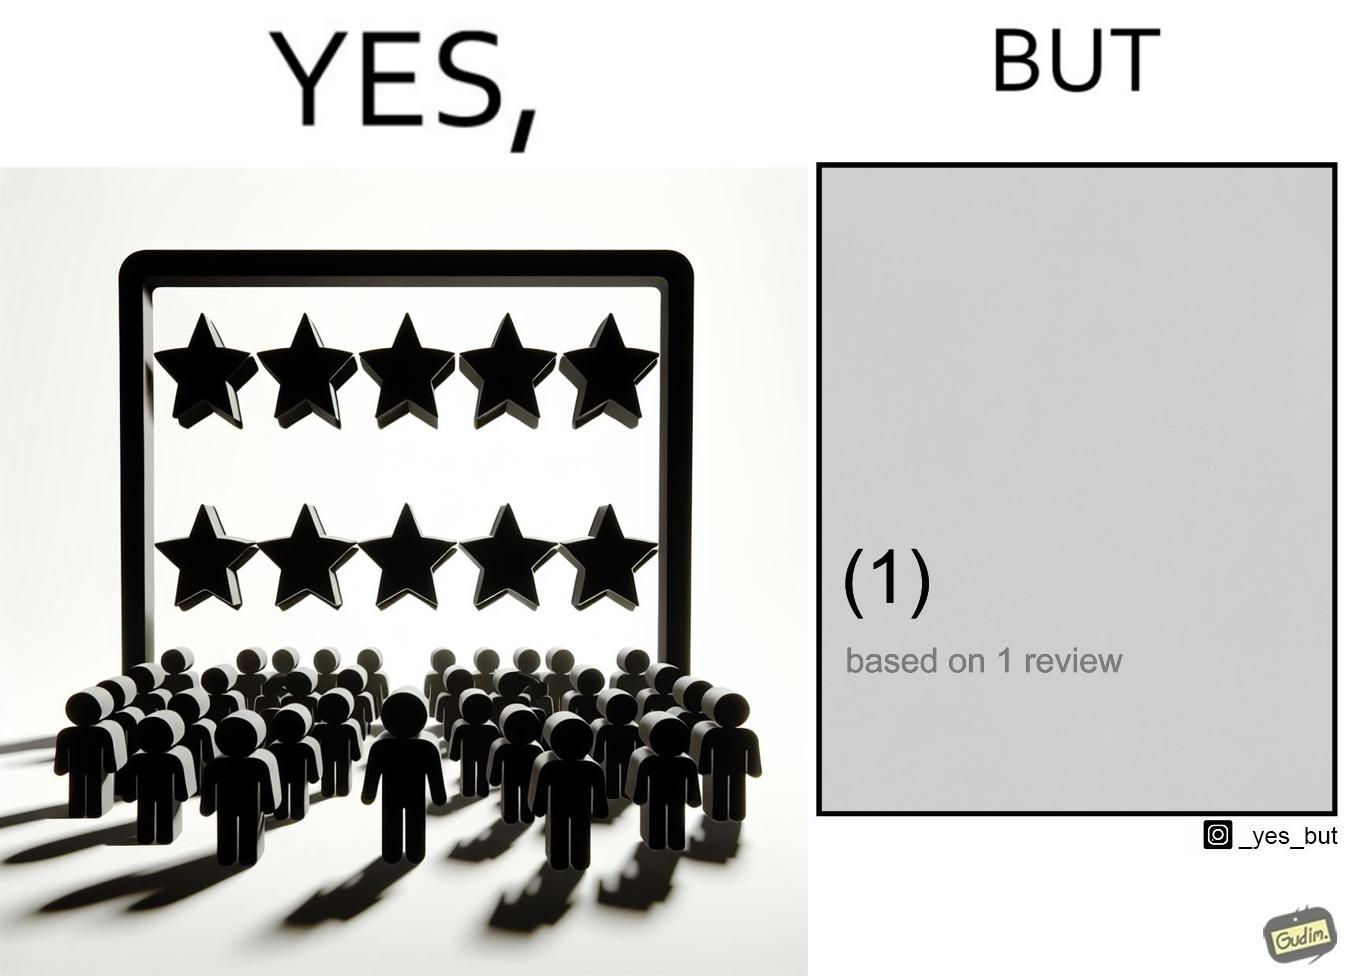Describe what you see in the left and right parts of this image. In the left part of the image: "Ratings and Reviews" showing that a product/service is rated 5 out of 5 stars. In the right part of the image: The rating is based on 1 review only 